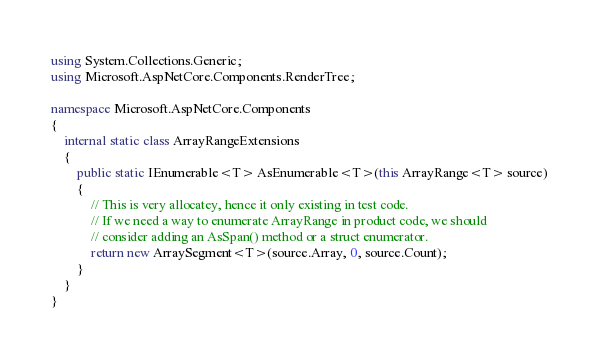<code> <loc_0><loc_0><loc_500><loc_500><_C#_>using System.Collections.Generic;
using Microsoft.AspNetCore.Components.RenderTree;

namespace Microsoft.AspNetCore.Components
{
    internal static class ArrayRangeExtensions
    {
        public static IEnumerable<T> AsEnumerable<T>(this ArrayRange<T> source)
        {
            // This is very allocatey, hence it only existing in test code.
            // If we need a way to enumerate ArrayRange in product code, we should
            // consider adding an AsSpan() method or a struct enumerator.
            return new ArraySegment<T>(source.Array, 0, source.Count);
        }
    }
}
</code> 